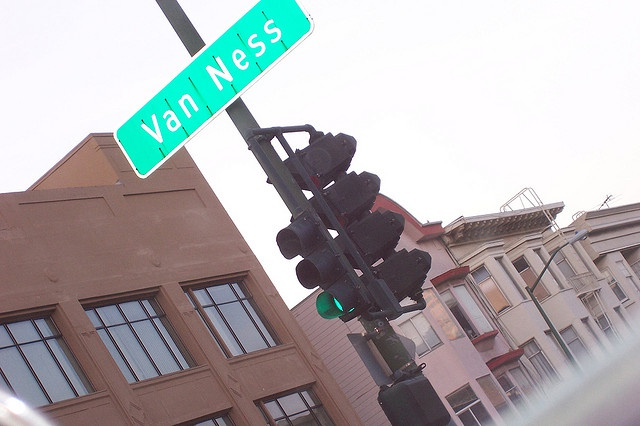Describe the objects in this image and their specific colors. I can see traffic light in white, gray, and black tones and traffic light in white, black, and gray tones in this image. 